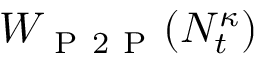<formula> <loc_0><loc_0><loc_500><loc_500>W _ { P 2 P } ( N _ { t } ^ { \kappa } )</formula> 